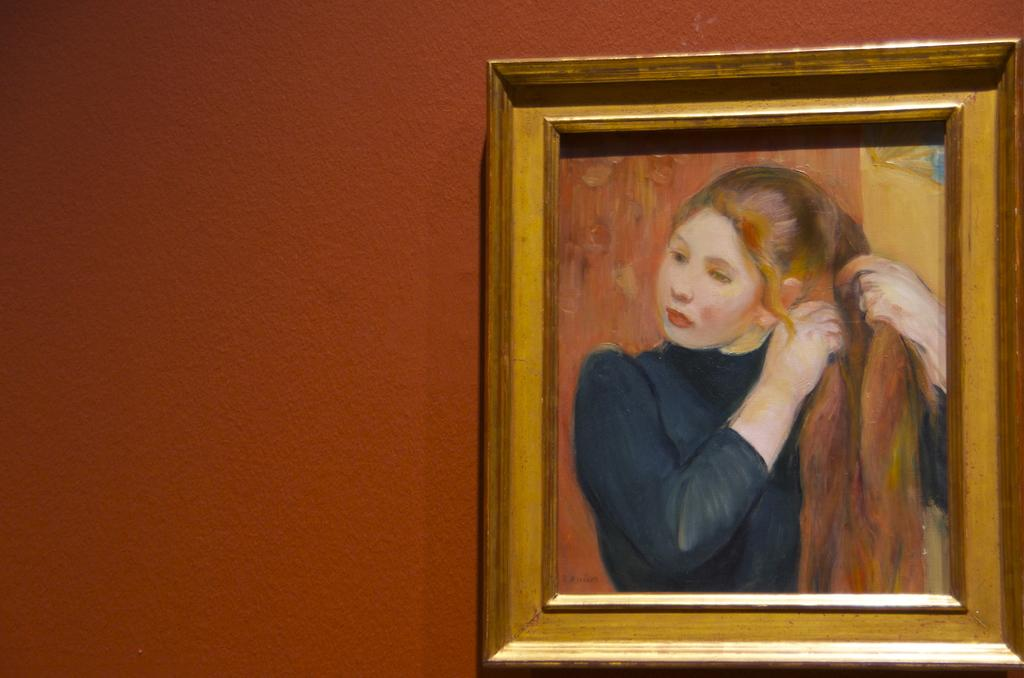What is on the wall in the image? There is a photo frame on the wall in the image. What is inside the photo frame? The photo frame contains a painting. What is the subject of the painting? The painting depicts a lady holding her hair. What type of fan is visible in the painting? There is no fan present in the painting; it depicts a lady holding her hair. What kind of fowl can be seen in the photo frame? There is no fowl present in the photo frame; it contains a painting of a lady holding her hair. 